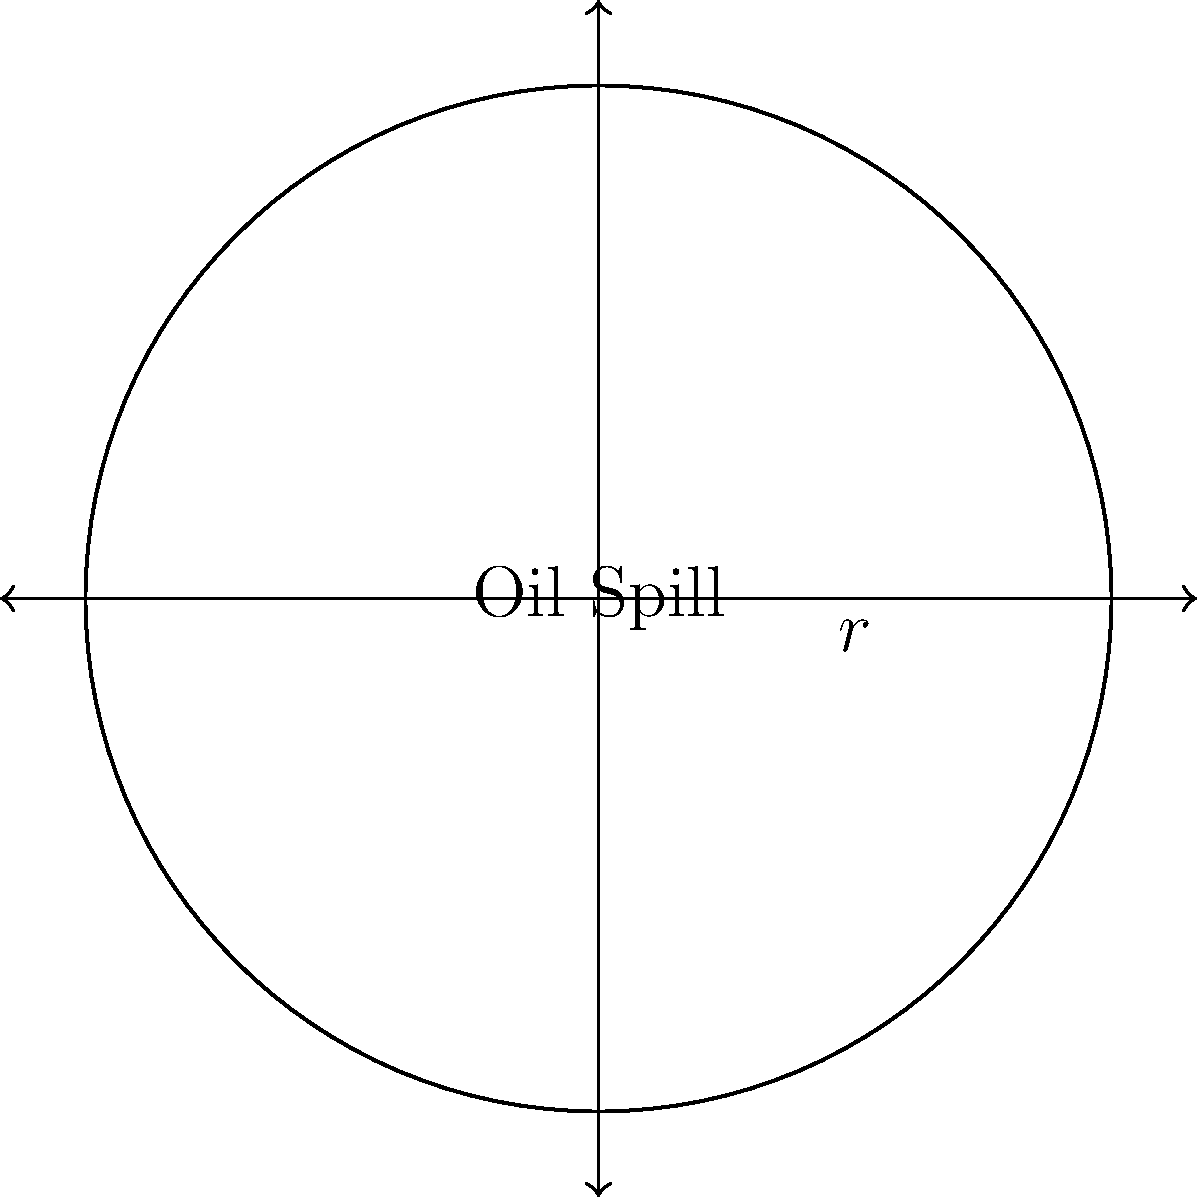During a routine marine pollution survey, you observe a circular oil spill with a radius of 500 meters. Calculate the total area of the ocean surface affected by this spill. Round your answer to the nearest square kilometer. To calculate the area of the circular oil spill, we'll use the formula for the area of a circle:

$$A = \pi r^2$$

Where:
$A$ = area of the circle
$\pi$ ≈ 3.14159
$r$ = radius of the circle

Given:
$r$ = 500 meters

Step 1: Substitute the radius into the formula
$$A = \pi (500\text{ m})^2$$

Step 2: Calculate the squared radius
$$A = \pi (250,000\text{ m}^2)$$

Step 3: Multiply by pi
$$A = 785,397.5\text{ m}^2$$

Step 4: Convert square meters to square kilometers
$$A = 785,397.5\text{ m}^2 \times \frac{1\text{ km}^2}{1,000,000\text{ m}^2} = 0.7854\text{ km}^2$$

Step 5: Round to the nearest square kilometer
$$A \approx 1\text{ km}^2$$
Answer: $1\text{ km}^2$ 